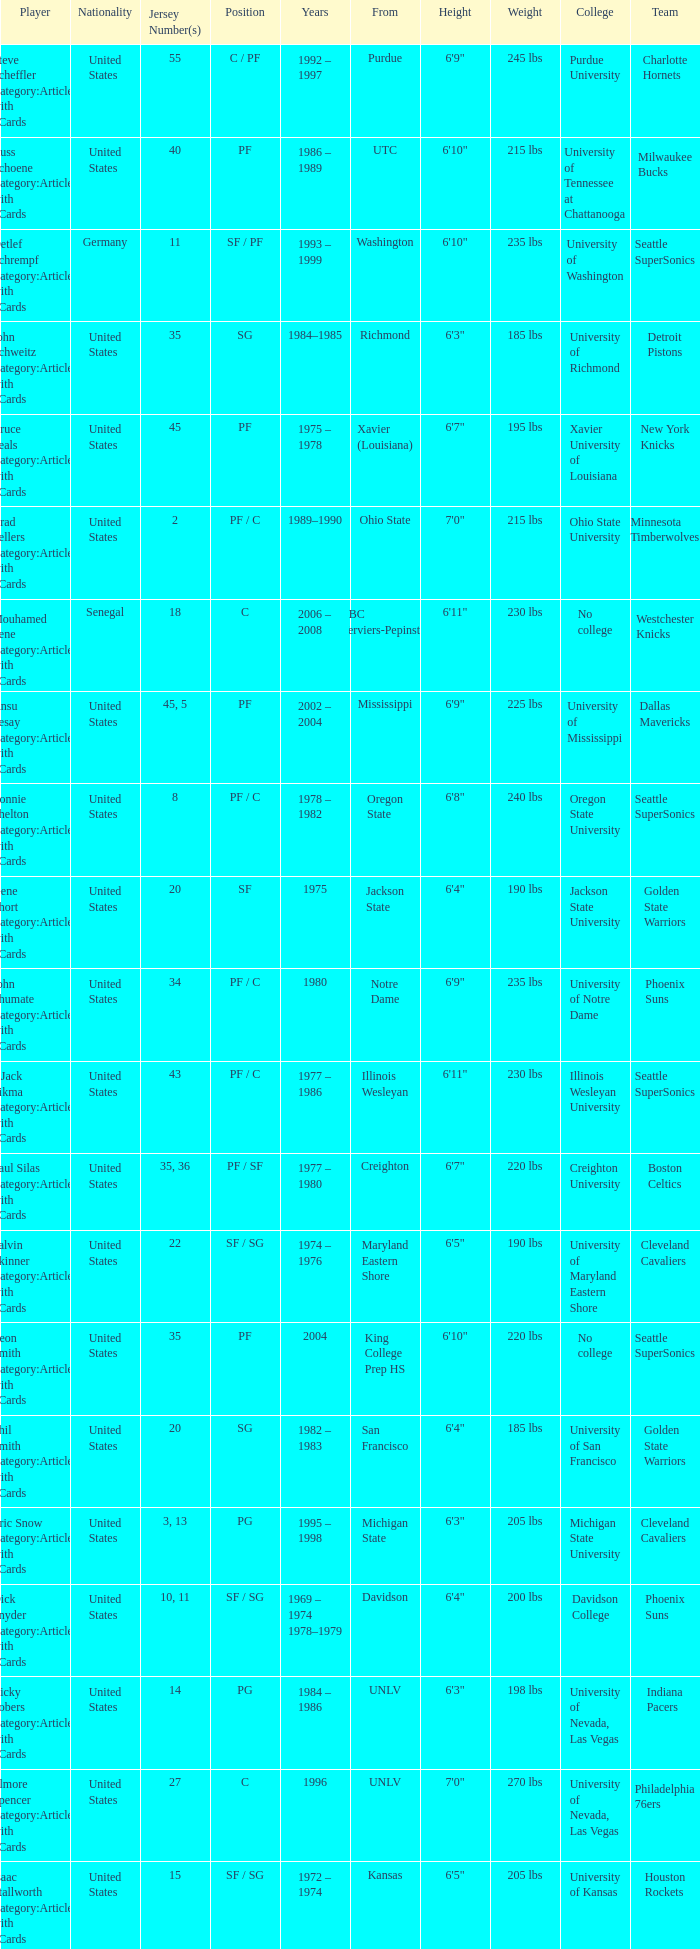What position does the player with jersey number 22 play? SF / SG. Write the full table. {'header': ['Player', 'Nationality', 'Jersey Number(s)', 'Position', 'Years', 'From', 'Height', 'Weight', 'College', 'Team'], 'rows': [['Steve Scheffler Category:Articles with hCards', 'United States', '55', 'C / PF', '1992 – 1997', 'Purdue', '6\'9"', '245 lbs', 'Purdue University', 'Charlotte Hornets'], ['Russ Schoene Category:Articles with hCards', 'United States', '40', 'PF', '1986 – 1989', 'UTC', '6\'10"', '215 lbs', 'University of Tennessee at Chattanooga', 'Milwaukee Bucks'], ['Detlef Schrempf Category:Articles with hCards', 'Germany', '11', 'SF / PF', '1993 – 1999', 'Washington', '6\'10"', '235 lbs', 'University of Washington', 'Seattle SuperSonics'], ['John Schweitz Category:Articles with hCards', 'United States', '35', 'SG', '1984–1985', 'Richmond', '6\'3"', '185 lbs', 'University of Richmond', 'Detroit Pistons'], ['Bruce Seals Category:Articles with hCards', 'United States', '45', 'PF', '1975 – 1978', 'Xavier (Louisiana)', '6\'7"', '195 lbs', 'Xavier University of Louisiana', 'New York Knicks'], ['Brad Sellers Category:Articles with hCards', 'United States', '2', 'PF / C', '1989–1990', 'Ohio State', '7\'0"', '215 lbs', 'Ohio State University', 'Minnesota Timberwolves'], ['Mouhamed Sene Category:Articles with hCards', 'Senegal', '18', 'C', '2006 – 2008', 'RBC Verviers-Pepinster', '6\'11"', '230 lbs', 'No college', 'Westchester Knicks'], ['Ansu Sesay Category:Articles with hCards', 'United States', '45, 5', 'PF', '2002 – 2004', 'Mississippi', '6\'9"', '225 lbs', 'University of Mississippi', 'Dallas Mavericks'], ['Lonnie Shelton Category:Articles with hCards', 'United States', '8', 'PF / C', '1978 – 1982', 'Oregon State', '6\'8"', '240 lbs', 'Oregon State University', 'Seattle SuperSonics'], ['Gene Short Category:Articles with hCards', 'United States', '20', 'SF', '1975', 'Jackson State', '6\'4"', '190 lbs', 'Jackson State University', 'Golden State Warriors'], ['John Shumate Category:Articles with hCards', 'United States', '34', 'PF / C', '1980', 'Notre Dame', '6\'9"', '235 lbs', 'University of Notre Dame', 'Phoenix Suns'], ['^ Jack Sikma Category:Articles with hCards', 'United States', '43', 'PF / C', '1977 – 1986', 'Illinois Wesleyan', '6\'11"', '230 lbs', 'Illinois Wesleyan University', 'Seattle SuperSonics'], ['Paul Silas Category:Articles with hCards', 'United States', '35, 36', 'PF / SF', '1977 – 1980', 'Creighton', '6\'7"', '220 lbs', 'Creighton University', 'Boston Celtics'], ['Talvin Skinner Category:Articles with hCards', 'United States', '22', 'SF / SG', '1974 – 1976', 'Maryland Eastern Shore', '6\'5"', '190 lbs', 'University of Maryland Eastern Shore', 'Cleveland Cavaliers'], ['Leon Smith Category:Articles with hCards', 'United States', '35', 'PF', '2004', 'King College Prep HS', '6\'10"', '220 lbs', 'No college', 'Seattle SuperSonics'], ['Phil Smith Category:Articles with hCards', 'United States', '20', 'SG', '1982 – 1983', 'San Francisco', '6\'4"', '185 lbs', 'University of San Francisco', 'Golden State Warriors'], ['Eric Snow Category:Articles with hCards', 'United States', '3, 13', 'PG', '1995 – 1998', 'Michigan State', '6\'3"', '205 lbs', 'Michigan State University', 'Cleveland Cavaliers'], ['Dick Snyder Category:Articles with hCards', 'United States', '10, 11', 'SF / SG', '1969 – 1974 1978–1979', 'Davidson', '6\'4"', '200 lbs', 'Davidson College', 'Phoenix Suns'], ['Ricky Sobers Category:Articles with hCards', 'United States', '14', 'PG', '1984 – 1986', 'UNLV', '6\'3"', '198 lbs', 'University of Nevada, Las Vegas', 'Indiana Pacers'], ['Elmore Spencer Category:Articles with hCards', 'United States', '27', 'C', '1996', 'UNLV', '7\'0"', '270 lbs', 'University of Nevada, Las Vegas', 'Philadelphia 76ers'], ['Isaac Stallworth Category:Articles with hCards', 'United States', '15', 'SF / SG', '1972 – 1974', 'Kansas', '6\'5"', '205 lbs', 'University of Kansas', 'Houston Rockets'], ['Terence Stansbury Category:Articles with hCards', 'United States', '44', 'SG', '1986–1987', 'Temple', '6\'5"', '192 lbs', 'Temple University', 'Indiana Pacers'], ['Vladimir Stepania Category:Articles with hCards', 'Georgia', '5', 'Center', '1999 – 2000', 'KK Union Olimpija', '7\'0"', '255 lbs', 'No college', 'Miami Heat '], ['Larry Stewart Category:Articles with hCards', 'United States', '23', 'SF', '1996–1997', 'Coppin State', '6\'8"', '220 lbs', 'Coppin State University', 'Seattle SuperSonics'], ['Alex Stivrins Category:Articles with hCards', 'United States', '42', 'PF', '1985', 'Colorado', '6\'11"', '238 lbs', 'University of Colorado', 'Seattle SuperSonics'], ['Jon Sundvold Category:Articles with hCards', 'United States', '20', 'SG', '1984 – 1985', 'Missouri', '6\'2"', '170 lbs', 'University of Missouri', 'Miami Heat'], ['Robert Swift Category:Articles with hCards', 'United States', '31', 'C', '2005 – 2008', 'Bakersfield HS', '7\'1"', '270 lbs', 'No college', 'Oklahoma City Thunder'], ['Wally Szczerbiak Category:Articles with hCards', 'United States', '3', 'SF / SG', '2007–2008', 'Miami (Ohio)', '6\'7"', '245 lbs', 'Miami University', 'Cleveland Cavaliers']]} 